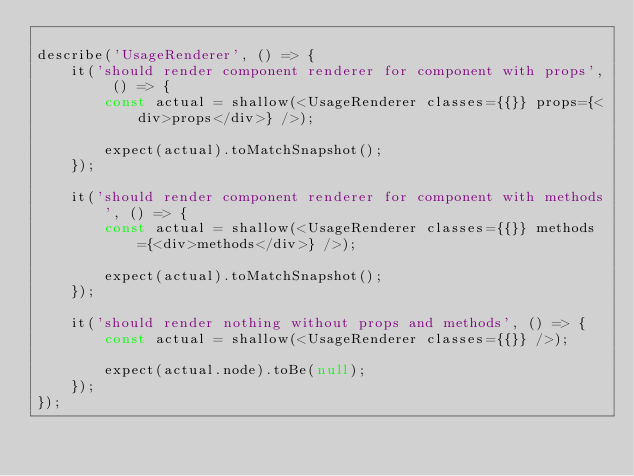<code> <loc_0><loc_0><loc_500><loc_500><_JavaScript_>
describe('UsageRenderer', () => {
	it('should render component renderer for component with props', () => {
		const actual = shallow(<UsageRenderer classes={{}} props={<div>props</div>} />);

		expect(actual).toMatchSnapshot();
	});

	it('should render component renderer for component with methods', () => {
		const actual = shallow(<UsageRenderer classes={{}} methods={<div>methods</div>} />);

		expect(actual).toMatchSnapshot();
	});

	it('should render nothing without props and methods', () => {
		const actual = shallow(<UsageRenderer classes={{}} />);

		expect(actual.node).toBe(null);
	});
});
</code> 